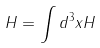<formula> <loc_0><loc_0><loc_500><loc_500>H = \int d ^ { 3 } x H</formula> 